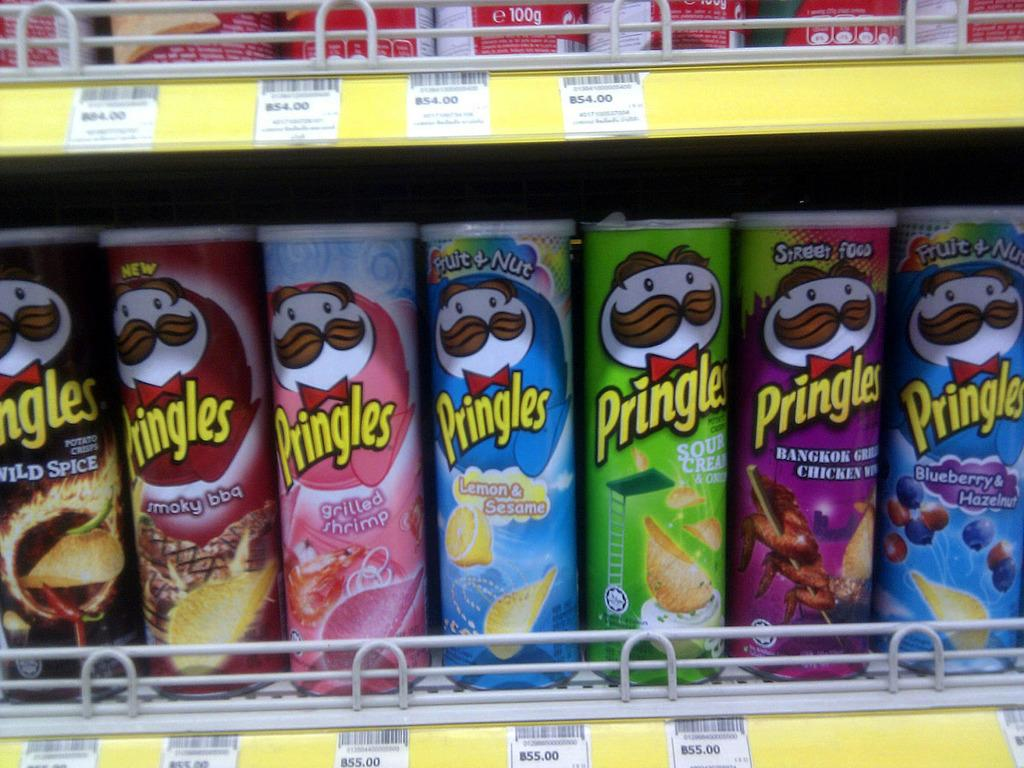<image>
Offer a succinct explanation of the picture presented. Several cans of Pringles chips sitting on a store shelf with prices underneath. 